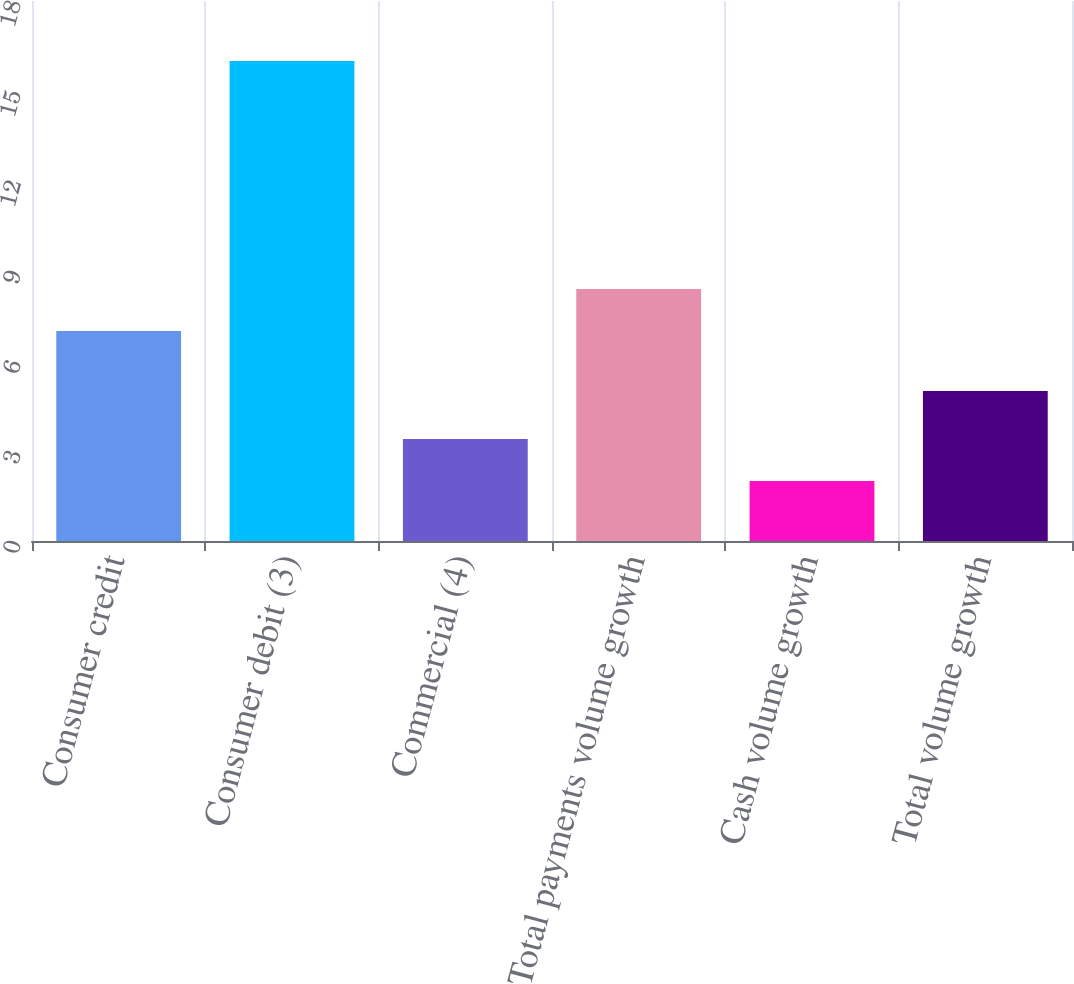<chart> <loc_0><loc_0><loc_500><loc_500><bar_chart><fcel>Consumer credit<fcel>Consumer debit (3)<fcel>Commercial (4)<fcel>Total payments volume growth<fcel>Cash volume growth<fcel>Total volume growth<nl><fcel>7<fcel>16<fcel>3.4<fcel>8.4<fcel>2<fcel>5<nl></chart> 